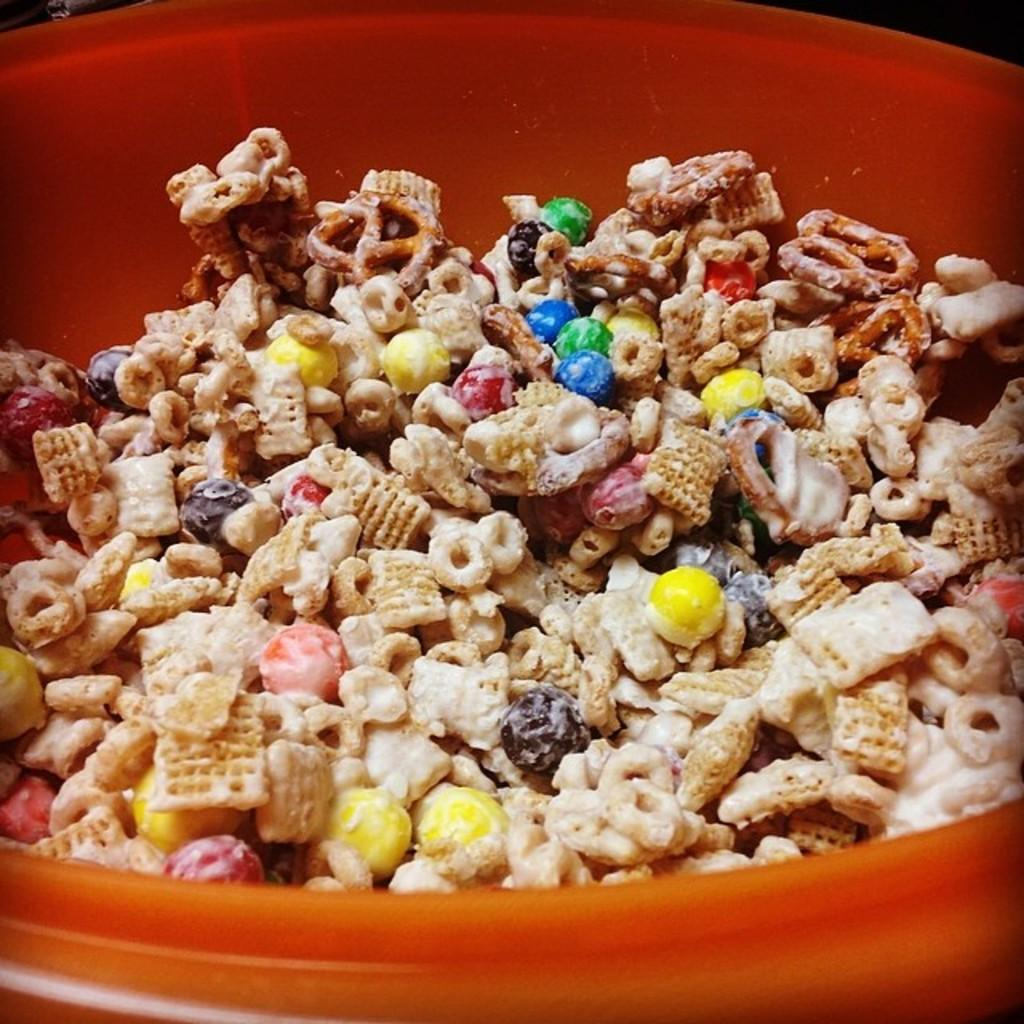What type of food can be seen in the image? There is a snack item in the image. How is the snack item prepared? The snack item is prepared with confectionaries. In what type of container is the snack item served? The snack item is served in a bowl. How many bikes are used to prepare the snack item in the image? There are no bikes involved in the preparation of the snack item in the image. What type of paste is used to hold the snack item together in the image? There is no paste mentioned or visible in the image; the snack item is prepared with confectionaries. 